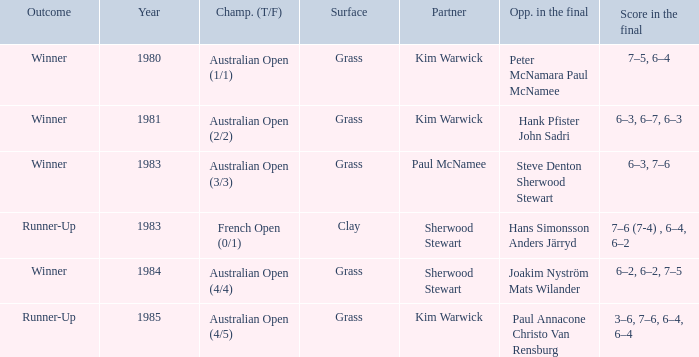How many different partners were played with during French Open (0/1)? 1.0. 